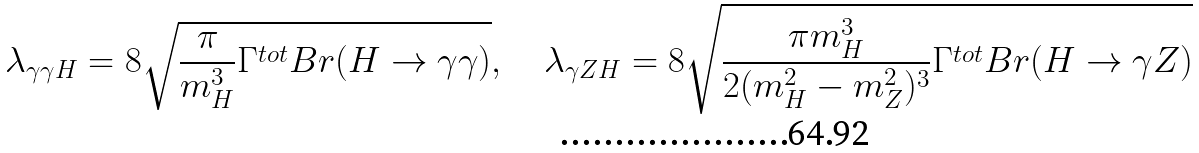<formula> <loc_0><loc_0><loc_500><loc_500>\lambda _ { \gamma \gamma H } = 8 \sqrt { \frac { \pi } { m ^ { 3 } _ { H } } \Gamma ^ { t o t } B r ( H \to \gamma \gamma ) } , \quad \lambda _ { \gamma Z H } = 8 \sqrt { \frac { \pi m ^ { 3 } _ { H } } { 2 ( m ^ { 2 } _ { H } - m ^ { 2 } _ { Z } ) ^ { 3 } } \Gamma ^ { t o t } B r ( H \to \gamma Z ) }</formula> 